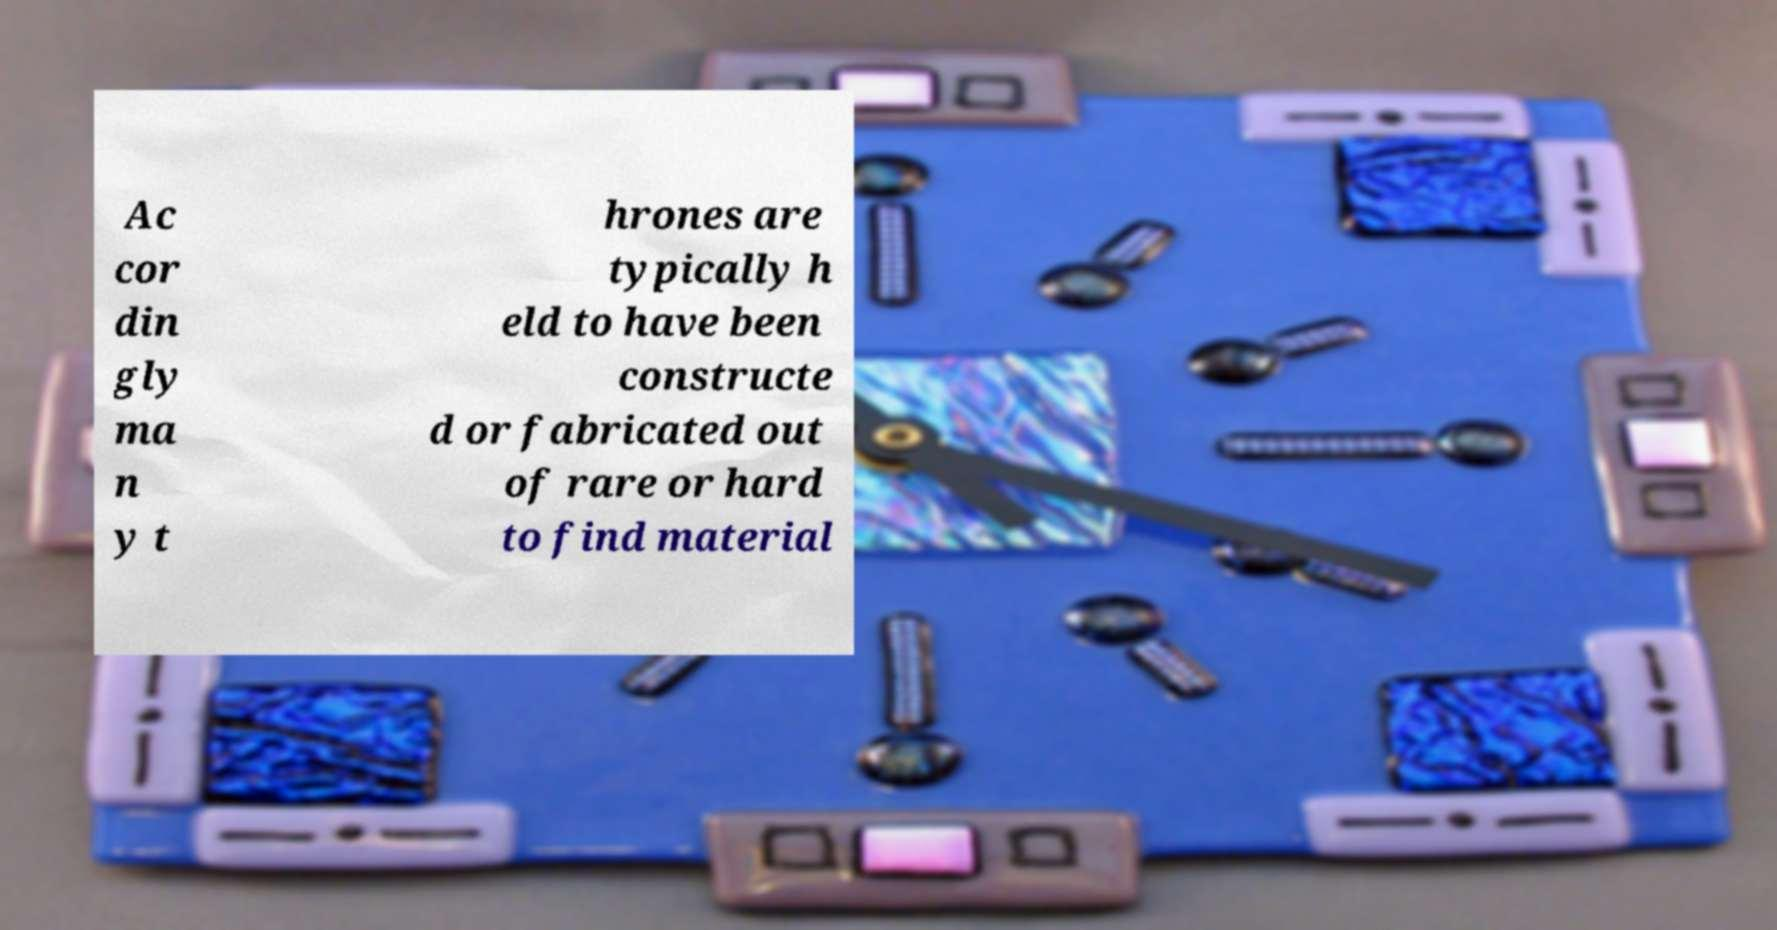Please read and relay the text visible in this image. What does it say? Ac cor din gly ma n y t hrones are typically h eld to have been constructe d or fabricated out of rare or hard to find material 